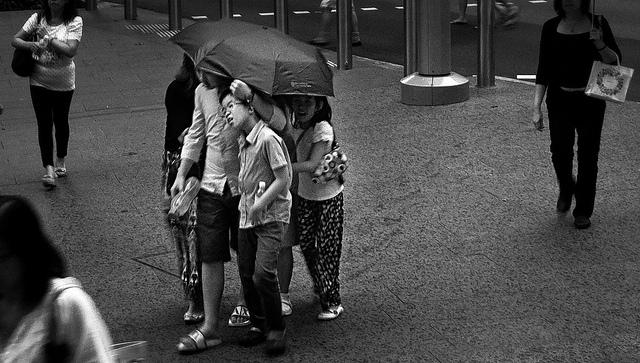What number is closest to how many people are under the middle umbrella?

Choices:
A) four
B) one
C) twenty
D) ten four 